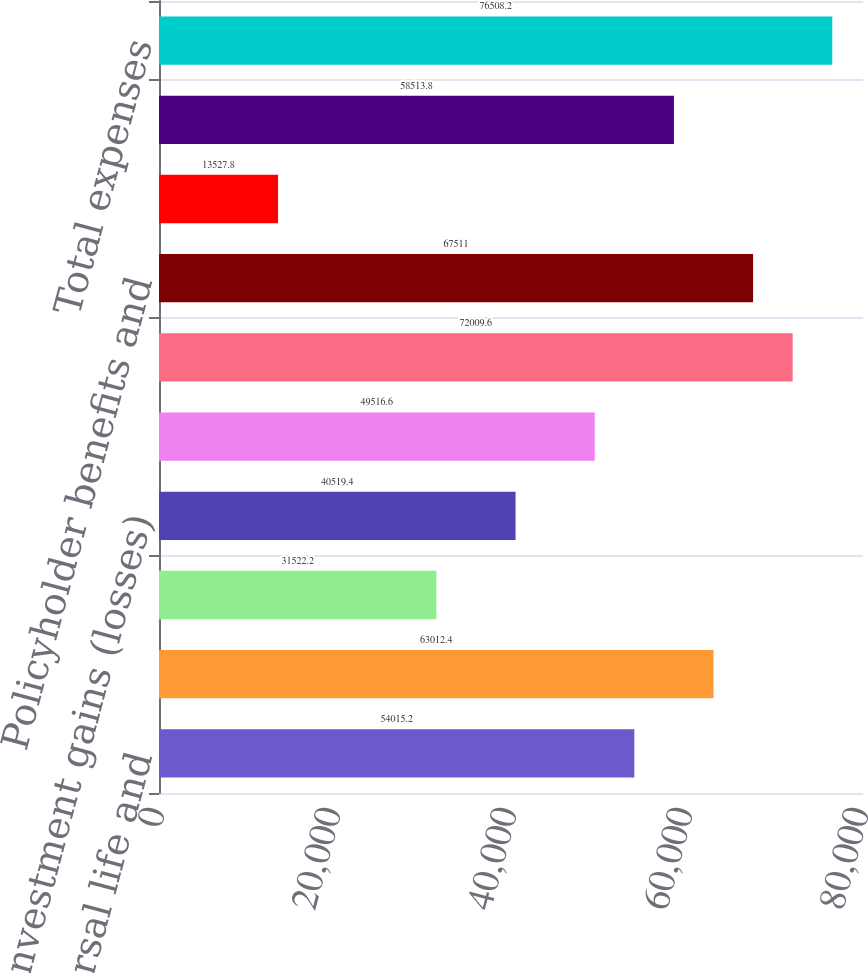<chart> <loc_0><loc_0><loc_500><loc_500><bar_chart><fcel>Universal life and<fcel>Net investment income<fcel>Other revenues<fcel>Net investment gains (losses)<fcel>Net derivative gains (losses)<fcel>Total revenues<fcel>Policyholder benefits and<fcel>Policyholder dividends<fcel>Other expenses<fcel>Total expenses<nl><fcel>54015.2<fcel>63012.4<fcel>31522.2<fcel>40519.4<fcel>49516.6<fcel>72009.6<fcel>67511<fcel>13527.8<fcel>58513.8<fcel>76508.2<nl></chart> 